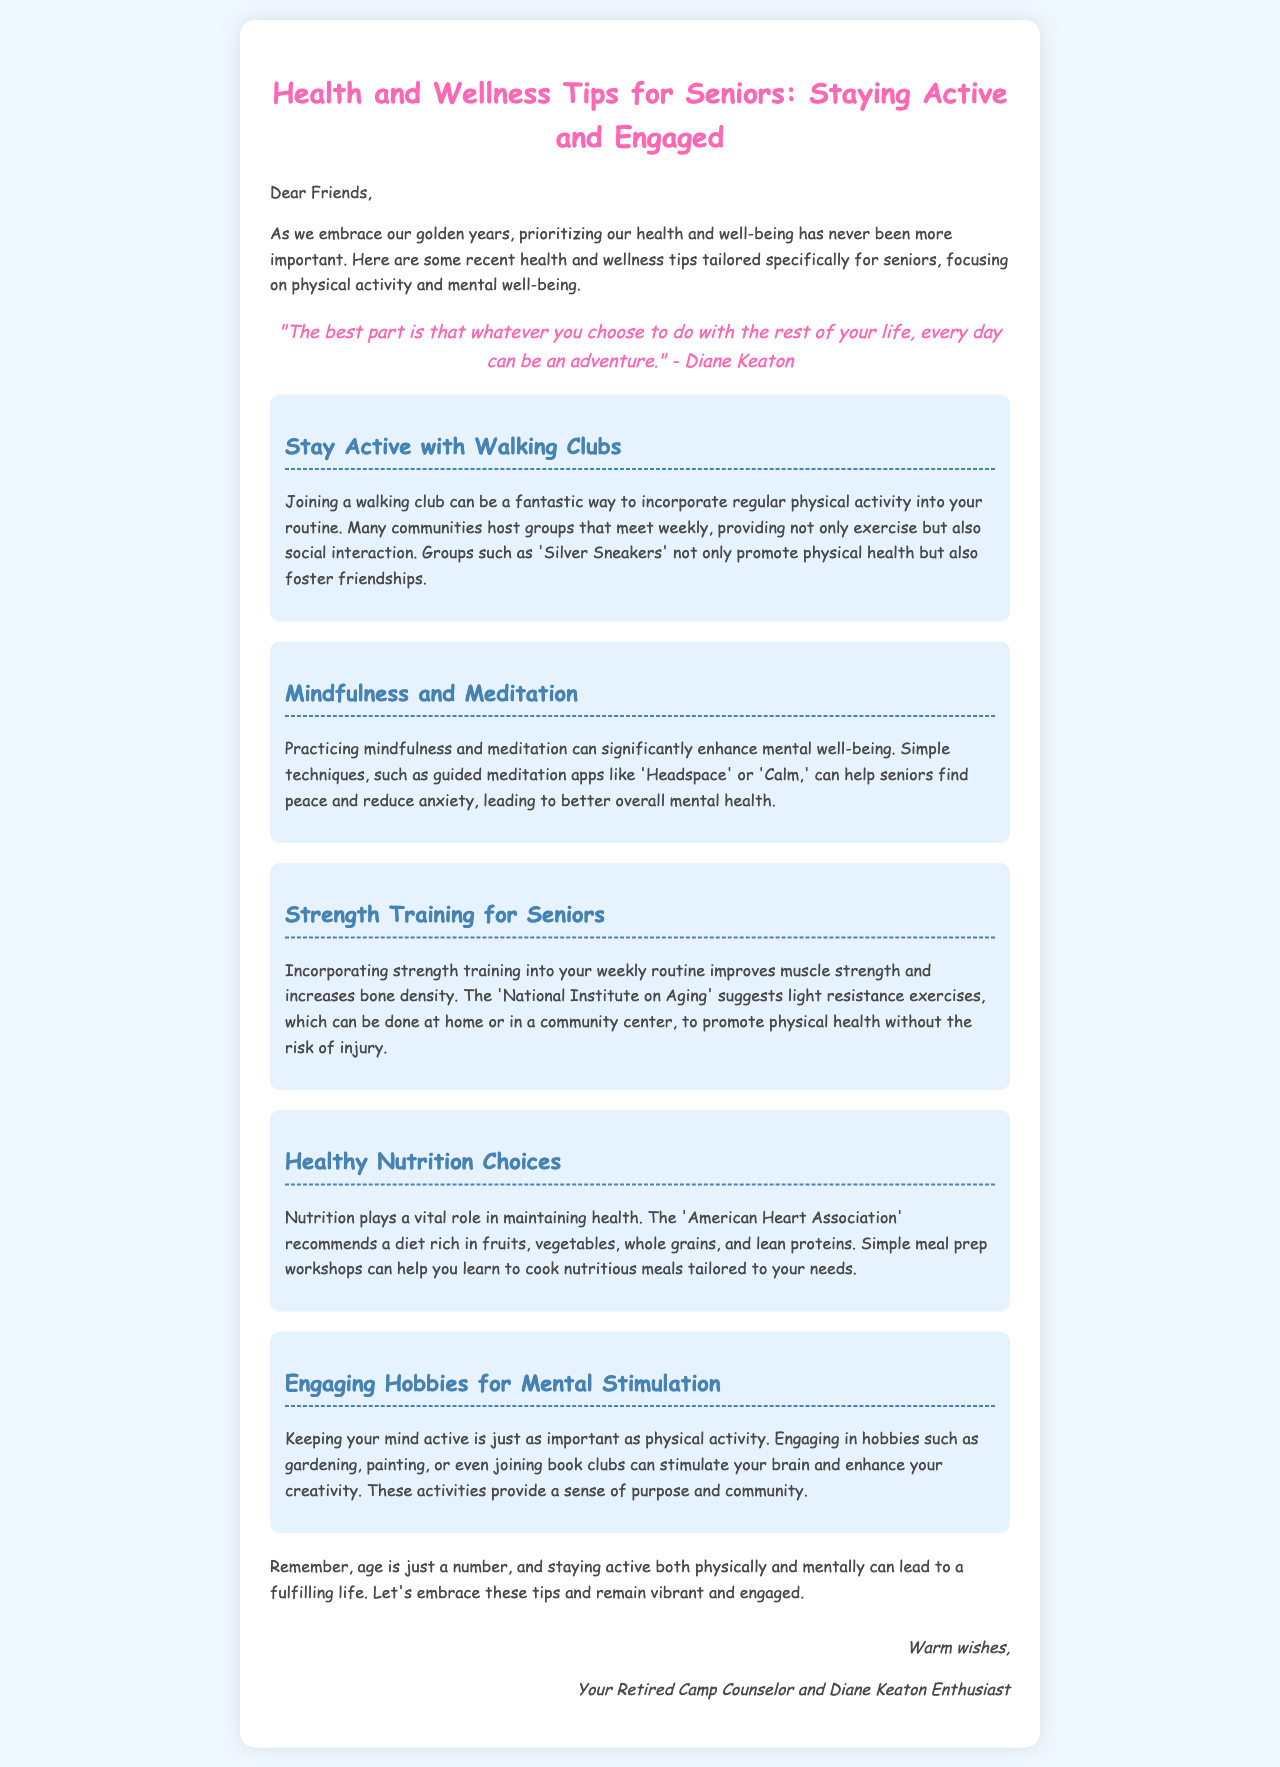What is the main focus of the health and wellness tips? The health and wellness tips focus on physical activity and mental well-being specifically for seniors.
Answer: Physical activity and mental well-being What is the name of the quote's author? The author of the quote in the document is mentioned distinctly.
Answer: Diane Keaton What type of exercise is suggested to improve muscle strength? The document specifies a certain kind of exercise for seniors related to muscle strength.
Answer: Strength training Which organization's recommendations are mentioned for a healthy diet? The document refers to an established organization that promotes healthy dietary habits in the tips provided.
Answer: American Heart Association What is one suggested activity for mental stimulation? The document lists various hobbies that enhance mental stimulation for seniors.
Answer: Gardening How many tips are provided in the email? The count of the health and wellness tips shared in the email helps to measure its content.
Answer: Five What is the suggested technology for mindfulness practices? The email mentions specific apps that can aid in mindfulness practices useful for seniors.
Answer: Headspace or Calm What is the recommended community activity for social interaction? The document discusses a communal activity that encourages both exercise and social engagement among seniors.
Answer: Walking clubs 